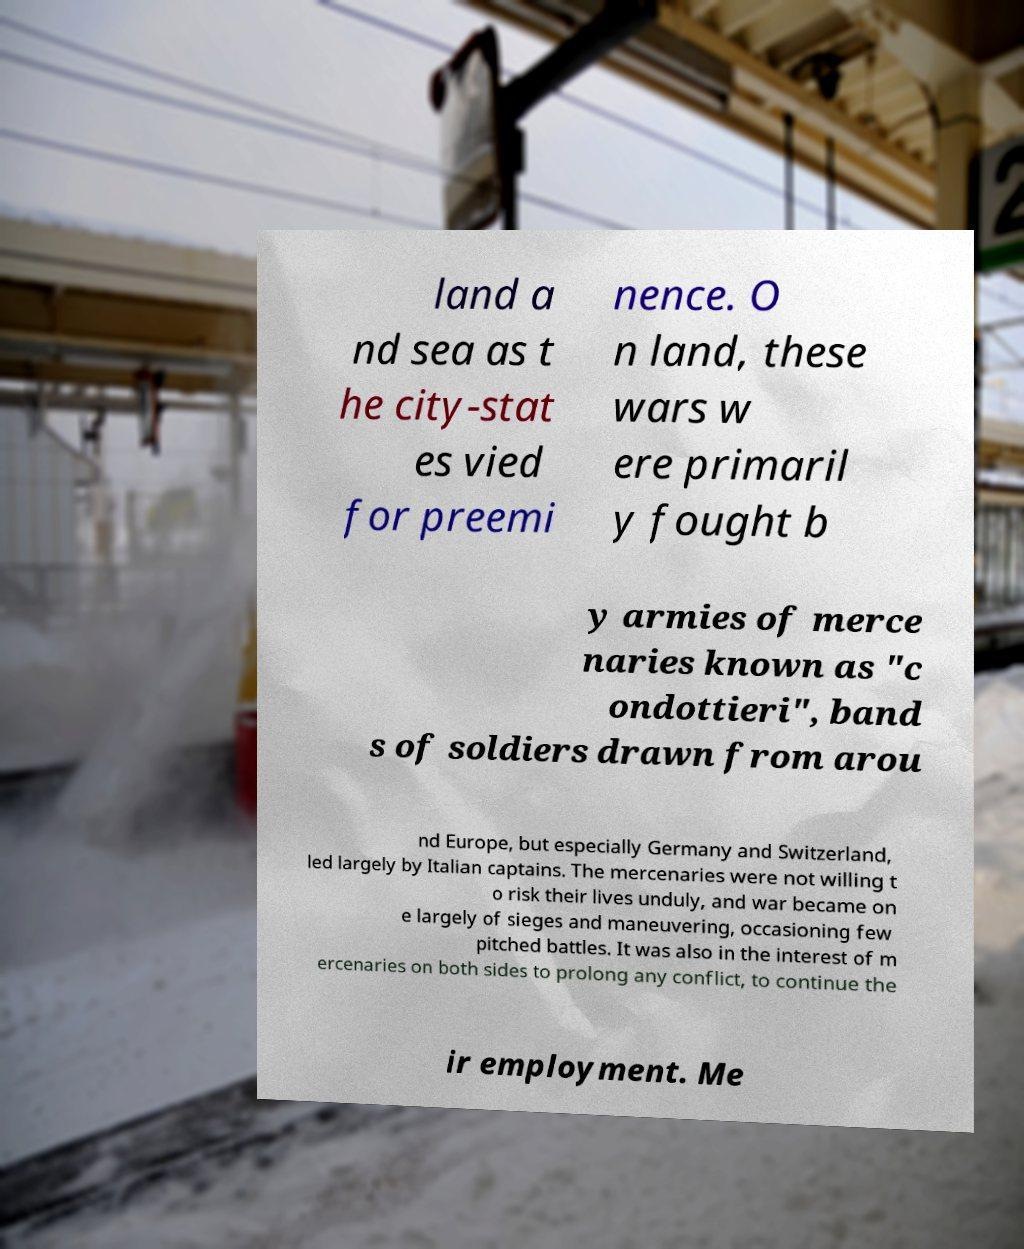What messages or text are displayed in this image? I need them in a readable, typed format. land a nd sea as t he city-stat es vied for preemi nence. O n land, these wars w ere primaril y fought b y armies of merce naries known as "c ondottieri", band s of soldiers drawn from arou nd Europe, but especially Germany and Switzerland, led largely by Italian captains. The mercenaries were not willing t o risk their lives unduly, and war became on e largely of sieges and maneuvering, occasioning few pitched battles. It was also in the interest of m ercenaries on both sides to prolong any conflict, to continue the ir employment. Me 